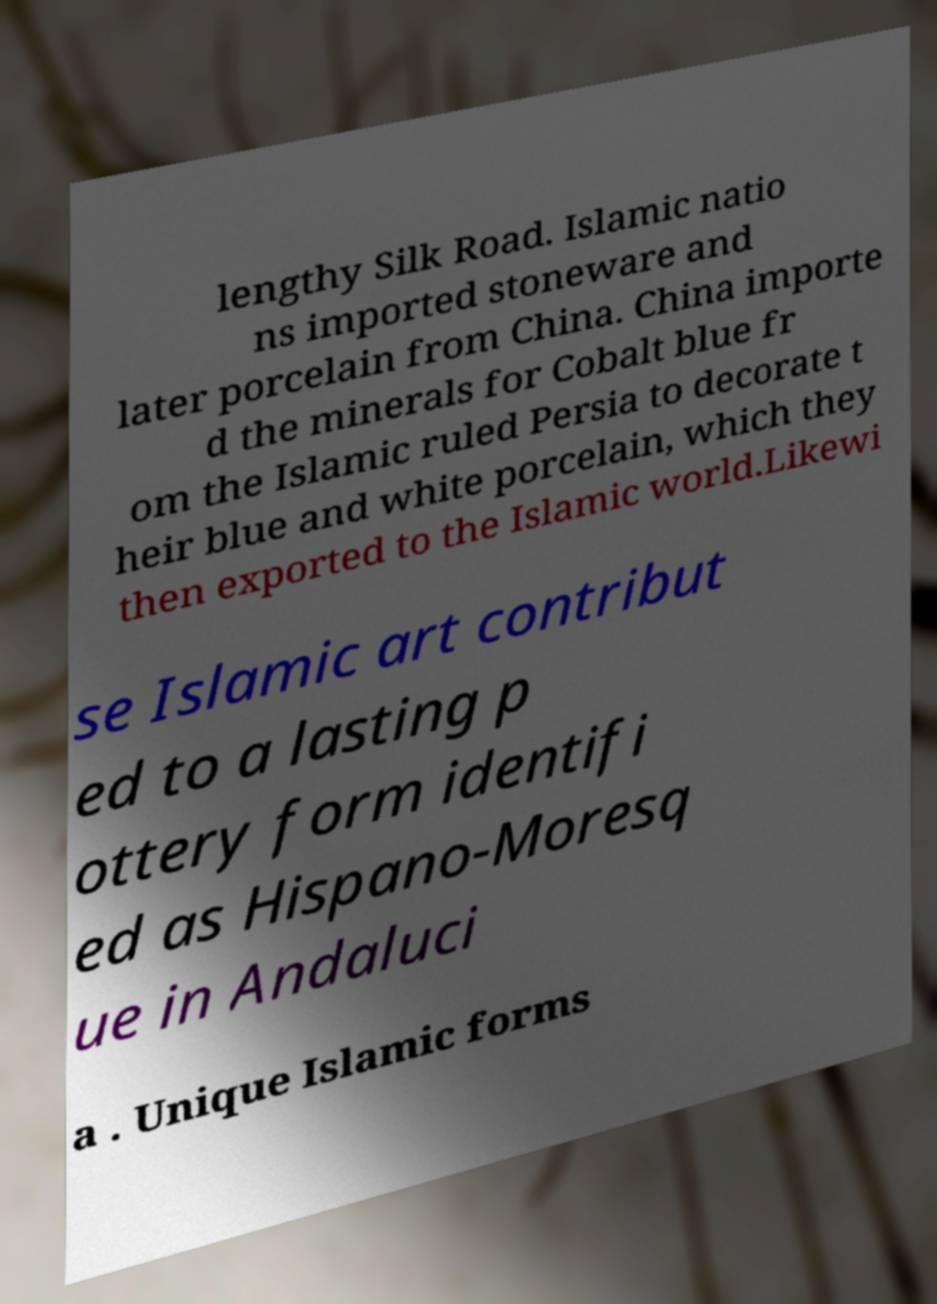Please identify and transcribe the text found in this image. lengthy Silk Road. Islamic natio ns imported stoneware and later porcelain from China. China importe d the minerals for Cobalt blue fr om the Islamic ruled Persia to decorate t heir blue and white porcelain, which they then exported to the Islamic world.Likewi se Islamic art contribut ed to a lasting p ottery form identifi ed as Hispano-Moresq ue in Andaluci a . Unique Islamic forms 